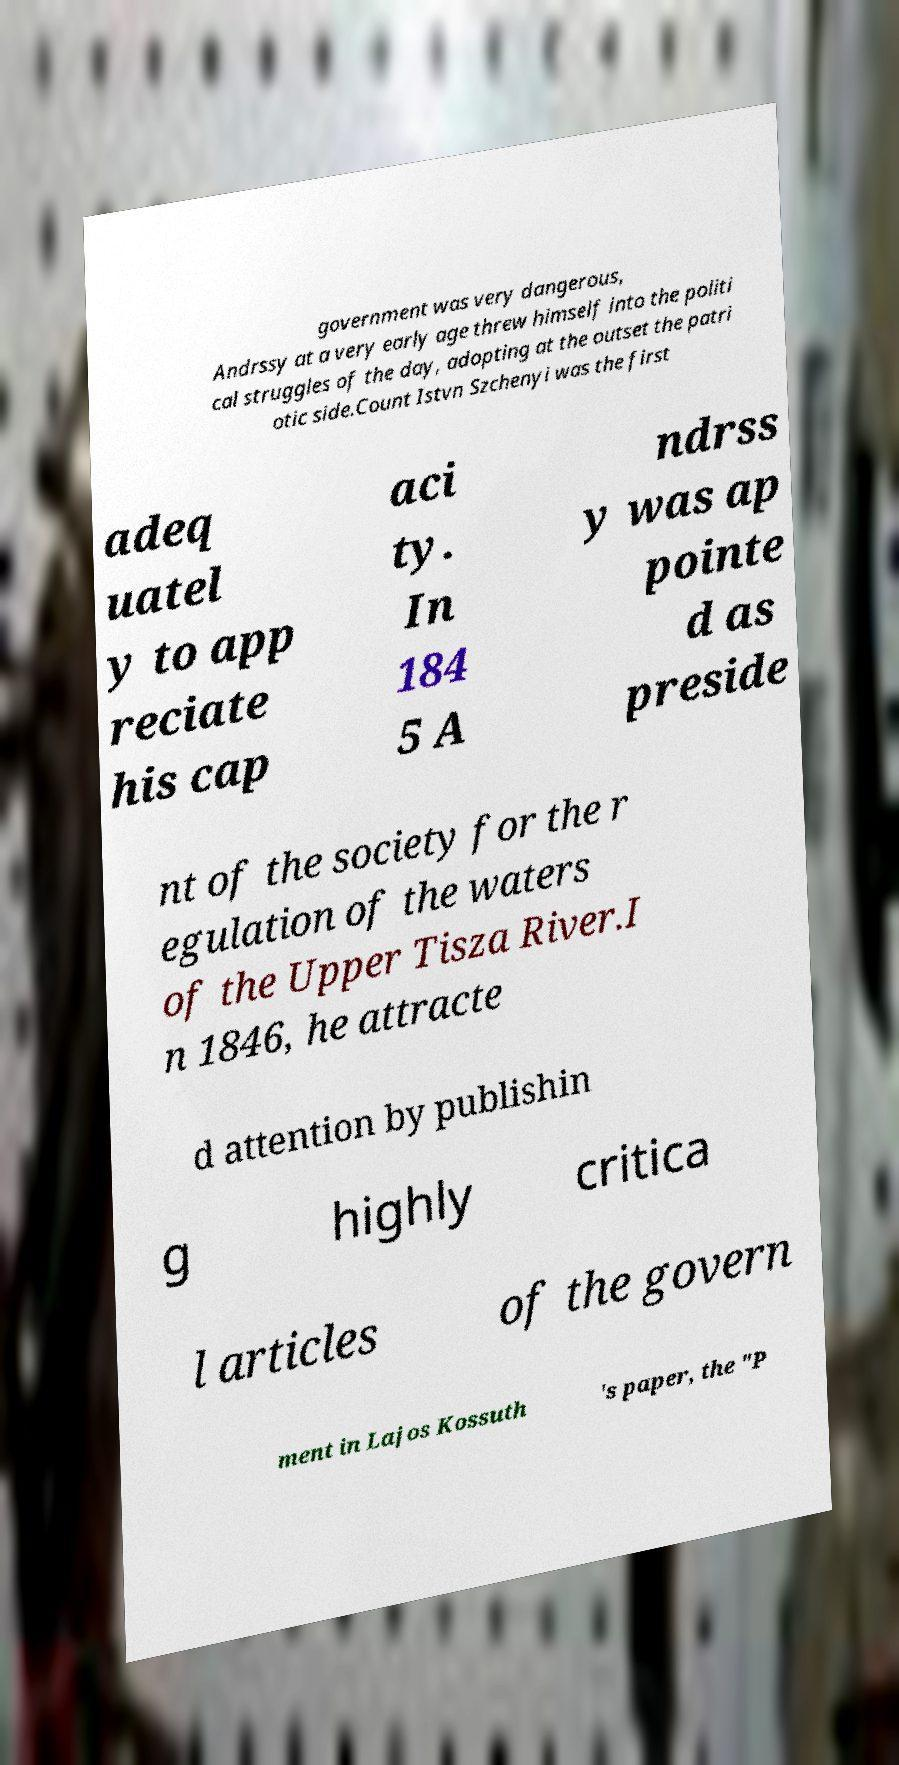There's text embedded in this image that I need extracted. Can you transcribe it verbatim? government was very dangerous, Andrssy at a very early age threw himself into the politi cal struggles of the day, adopting at the outset the patri otic side.Count Istvn Szchenyi was the first adeq uatel y to app reciate his cap aci ty. In 184 5 A ndrss y was ap pointe d as preside nt of the society for the r egulation of the waters of the Upper Tisza River.I n 1846, he attracte d attention by publishin g highly critica l articles of the govern ment in Lajos Kossuth 's paper, the "P 